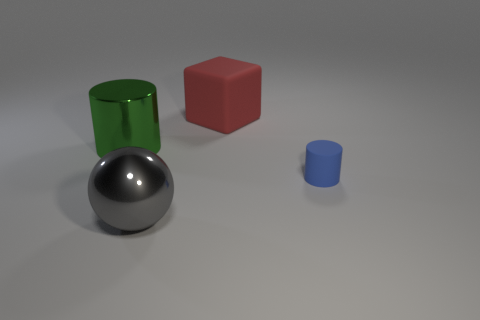Add 4 big gray metallic blocks. How many objects exist? 8 Subtract all green cylinders. How many cylinders are left? 1 Subtract 1 spheres. How many spheres are left? 0 Add 1 large shiny spheres. How many large shiny spheres are left? 2 Add 4 blocks. How many blocks exist? 5 Subtract 0 gray blocks. How many objects are left? 4 Subtract all yellow spheres. Subtract all cyan cylinders. How many spheres are left? 1 Subtract all big gray matte blocks. Subtract all tiny blue objects. How many objects are left? 3 